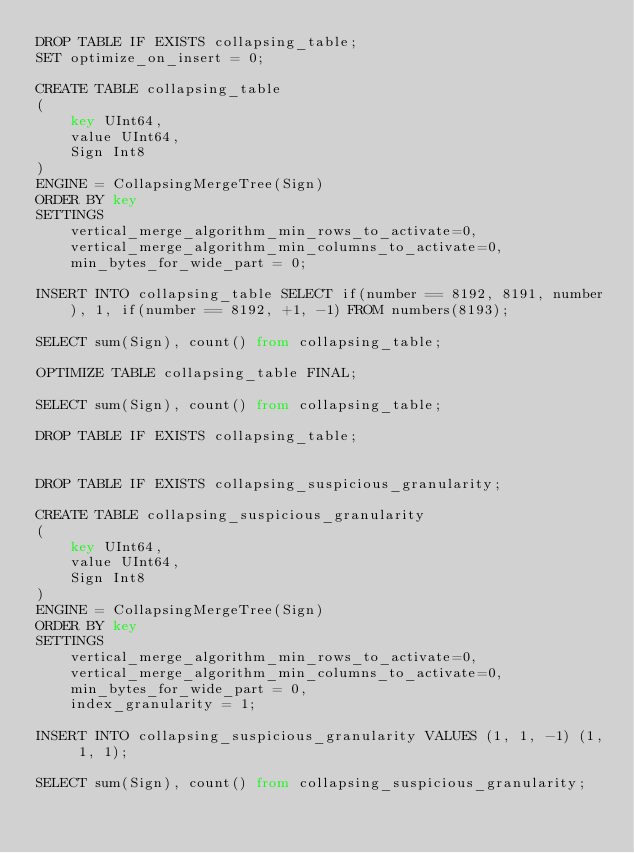Convert code to text. <code><loc_0><loc_0><loc_500><loc_500><_SQL_>DROP TABLE IF EXISTS collapsing_table;
SET optimize_on_insert = 0;

CREATE TABLE collapsing_table
(
    key UInt64,
    value UInt64,
    Sign Int8
)
ENGINE = CollapsingMergeTree(Sign)
ORDER BY key
SETTINGS
    vertical_merge_algorithm_min_rows_to_activate=0,
    vertical_merge_algorithm_min_columns_to_activate=0,
    min_bytes_for_wide_part = 0;

INSERT INTO collapsing_table SELECT if(number == 8192, 8191, number), 1, if(number == 8192, +1, -1) FROM numbers(8193);

SELECT sum(Sign), count() from collapsing_table;

OPTIMIZE TABLE collapsing_table FINAL;

SELECT sum(Sign), count() from collapsing_table;

DROP TABLE IF EXISTS collapsing_table;


DROP TABLE IF EXISTS collapsing_suspicious_granularity;

CREATE TABLE collapsing_suspicious_granularity
(
    key UInt64,
    value UInt64,
    Sign Int8
)
ENGINE = CollapsingMergeTree(Sign)
ORDER BY key
SETTINGS
    vertical_merge_algorithm_min_rows_to_activate=0,
    vertical_merge_algorithm_min_columns_to_activate=0,
    min_bytes_for_wide_part = 0,
    index_granularity = 1;

INSERT INTO collapsing_suspicious_granularity VALUES (1, 1, -1) (1, 1, 1);

SELECT sum(Sign), count() from collapsing_suspicious_granularity;
</code> 